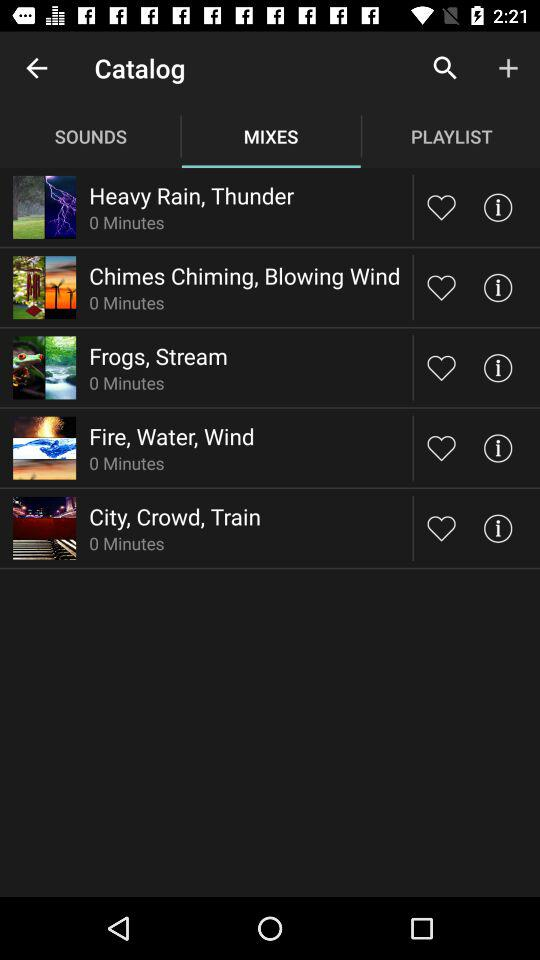What is the length of "City, Crowd, Train"? The length of "City, Crowd, Train" is 0 minutes. 